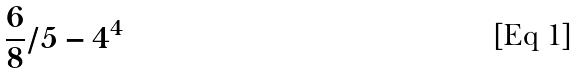Convert formula to latex. <formula><loc_0><loc_0><loc_500><loc_500>\frac { 6 } { 8 } / 5 - 4 ^ { 4 }</formula> 